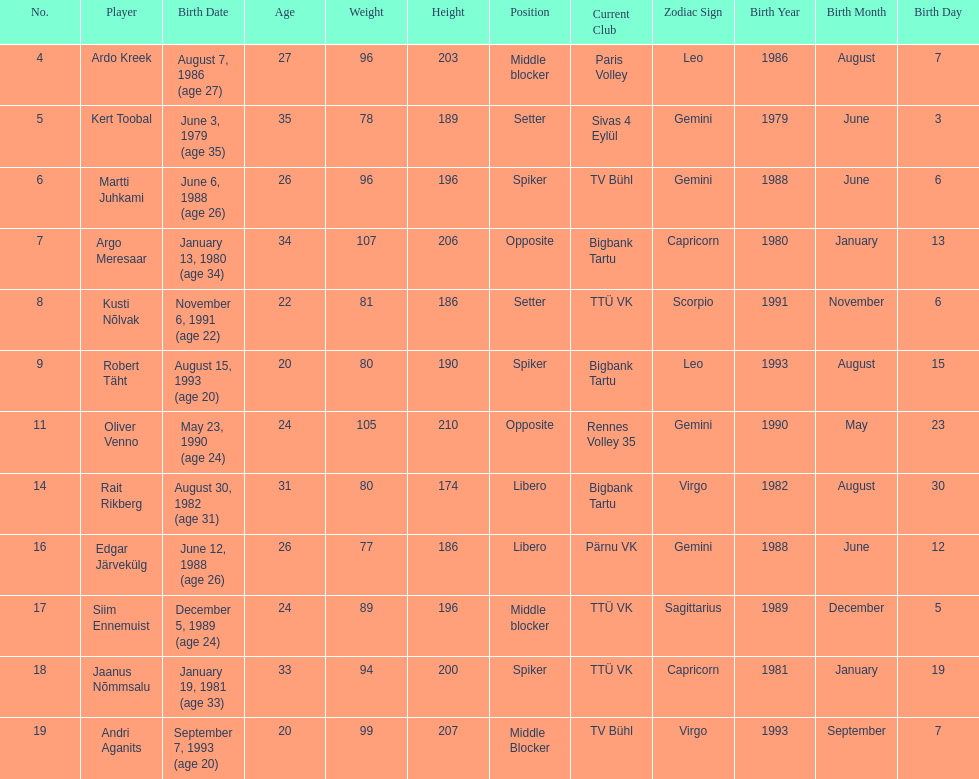Which players played the same position as ardo kreek? Siim Ennemuist, Andri Aganits. 